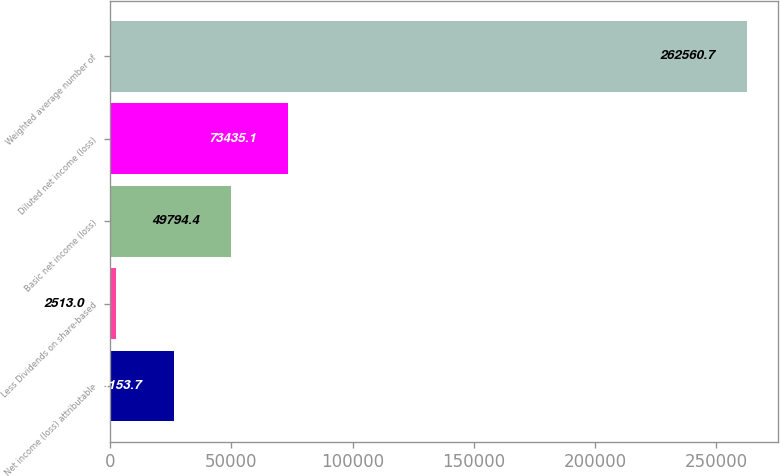Convert chart. <chart><loc_0><loc_0><loc_500><loc_500><bar_chart><fcel>Net income (loss) attributable<fcel>Less Dividends on share-based<fcel>Basic net income (loss)<fcel>Diluted net income (loss)<fcel>Weighted average number of<nl><fcel>26153.7<fcel>2513<fcel>49794.4<fcel>73435.1<fcel>262561<nl></chart> 